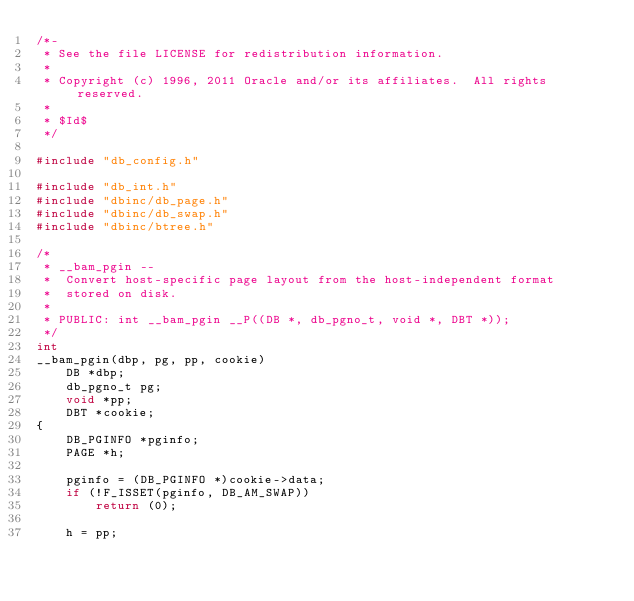Convert code to text. <code><loc_0><loc_0><loc_500><loc_500><_C_>/*-
 * See the file LICENSE for redistribution information.
 *
 * Copyright (c) 1996, 2011 Oracle and/or its affiliates.  All rights reserved.
 *
 * $Id$
 */

#include "db_config.h"

#include "db_int.h"
#include "dbinc/db_page.h"
#include "dbinc/db_swap.h"
#include "dbinc/btree.h"

/*
 * __bam_pgin --
 *	Convert host-specific page layout from the host-independent format
 *	stored on disk.
 *
 * PUBLIC: int __bam_pgin __P((DB *, db_pgno_t, void *, DBT *));
 */
int
__bam_pgin(dbp, pg, pp, cookie)
	DB *dbp;
	db_pgno_t pg;
	void *pp;
	DBT *cookie;
{
	DB_PGINFO *pginfo;
	PAGE *h;

	pginfo = (DB_PGINFO *)cookie->data;
	if (!F_ISSET(pginfo, DB_AM_SWAP))
		return (0);

	h = pp;</code> 